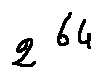<formula> <loc_0><loc_0><loc_500><loc_500>2 ^ { 6 4 }</formula> 